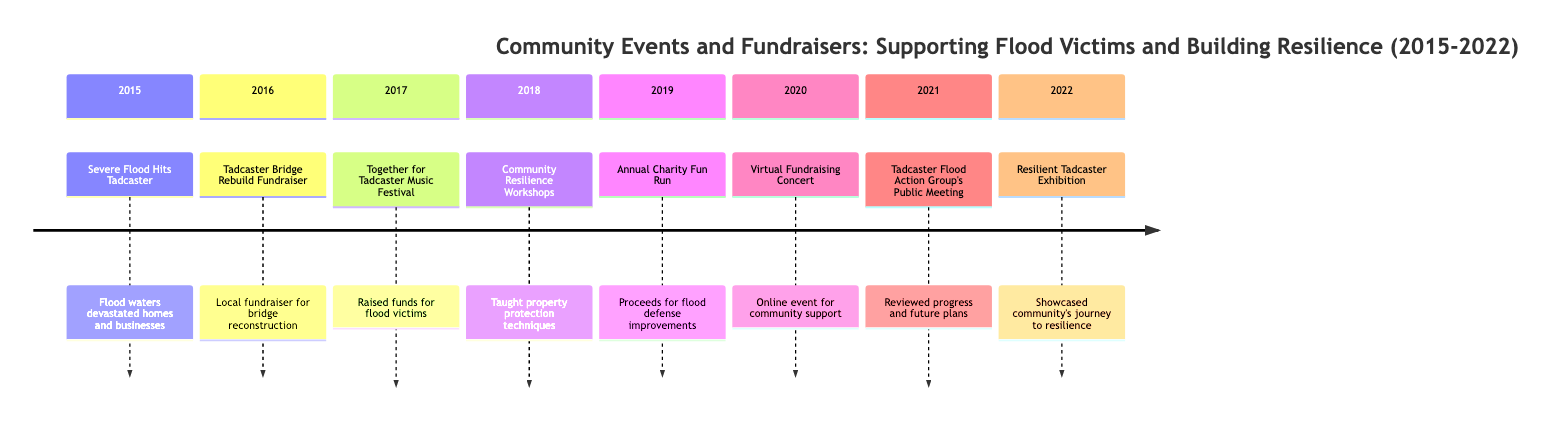What year did the severe flood hit Tadcaster? The timeline clearly indicates that the event "Severe Flood Hits Tadcaster" occurred in the year 2015.
Answer: 2015 Which event followed the Tadcaster Bridge Rebuild Fundraiser in the timeline? The event "Together for Tadcaster Music Festival" took place in 2017, immediately following the 2016 fundraiser.
Answer: Together for Tadcaster Music Festival How many total events are listed in the timeline? There are eight events described in the timeline from 2015 to 2022. Counting each event listed gives the total of eight.
Answer: 8 What event took place in 2019? According to the timeline, the event in 2019 is "Annual Charity Fun Run."
Answer: Annual Charity Fun Run Which year had two events focused on community resilience? The years 2018 and 2021 both had events related to building resilience: "Community Resilience Workshops" in 2018 and "Tadcaster Flood Action Group's Public Meeting" in 2021.
Answer: 2018 and 2021 What fundraising event occurred virtually in 2020? The "Virtual Fundraising Concert" is mentioned in 2020 as an online event to raise money during the pandemic.
Answer: Virtual Fundraising Concert Which event was specifically aimed at teaching property protection techniques? The event "Community Resilience Workshops" which happened in 2018 aimed at teaching residents protection techniques against flooding.
Answer: Community Resilience Workshops What was the purpose of the Annual Charity Fun Run? The proceeds from the Annual Charity Fun Run were designated for improvements in flood defenses, as stated in the 2019 section of the timeline.
Answer: Proceeds for flood defense improvements What exhibition showcased the community's journey from the 2015 flood? The "Resilient Tadcaster Exhibition" held in 2022 specifically showcased the community's journey from the flood to resilience.
Answer: Resilient Tadcaster Exhibition 